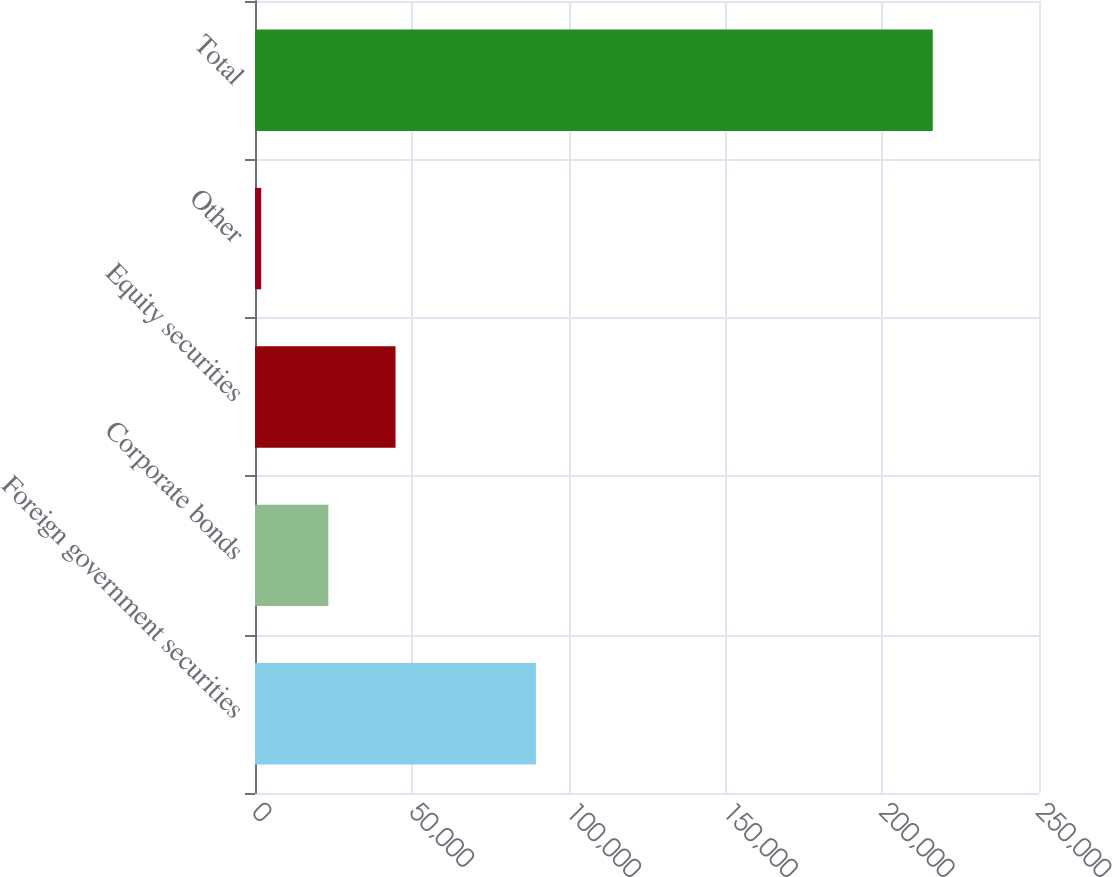Convert chart. <chart><loc_0><loc_0><loc_500><loc_500><bar_chart><fcel>Foreign government securities<fcel>Corporate bonds<fcel>Equity securities<fcel>Other<fcel>Total<nl><fcel>89576<fcel>23393.3<fcel>44807.6<fcel>1979<fcel>216122<nl></chart> 